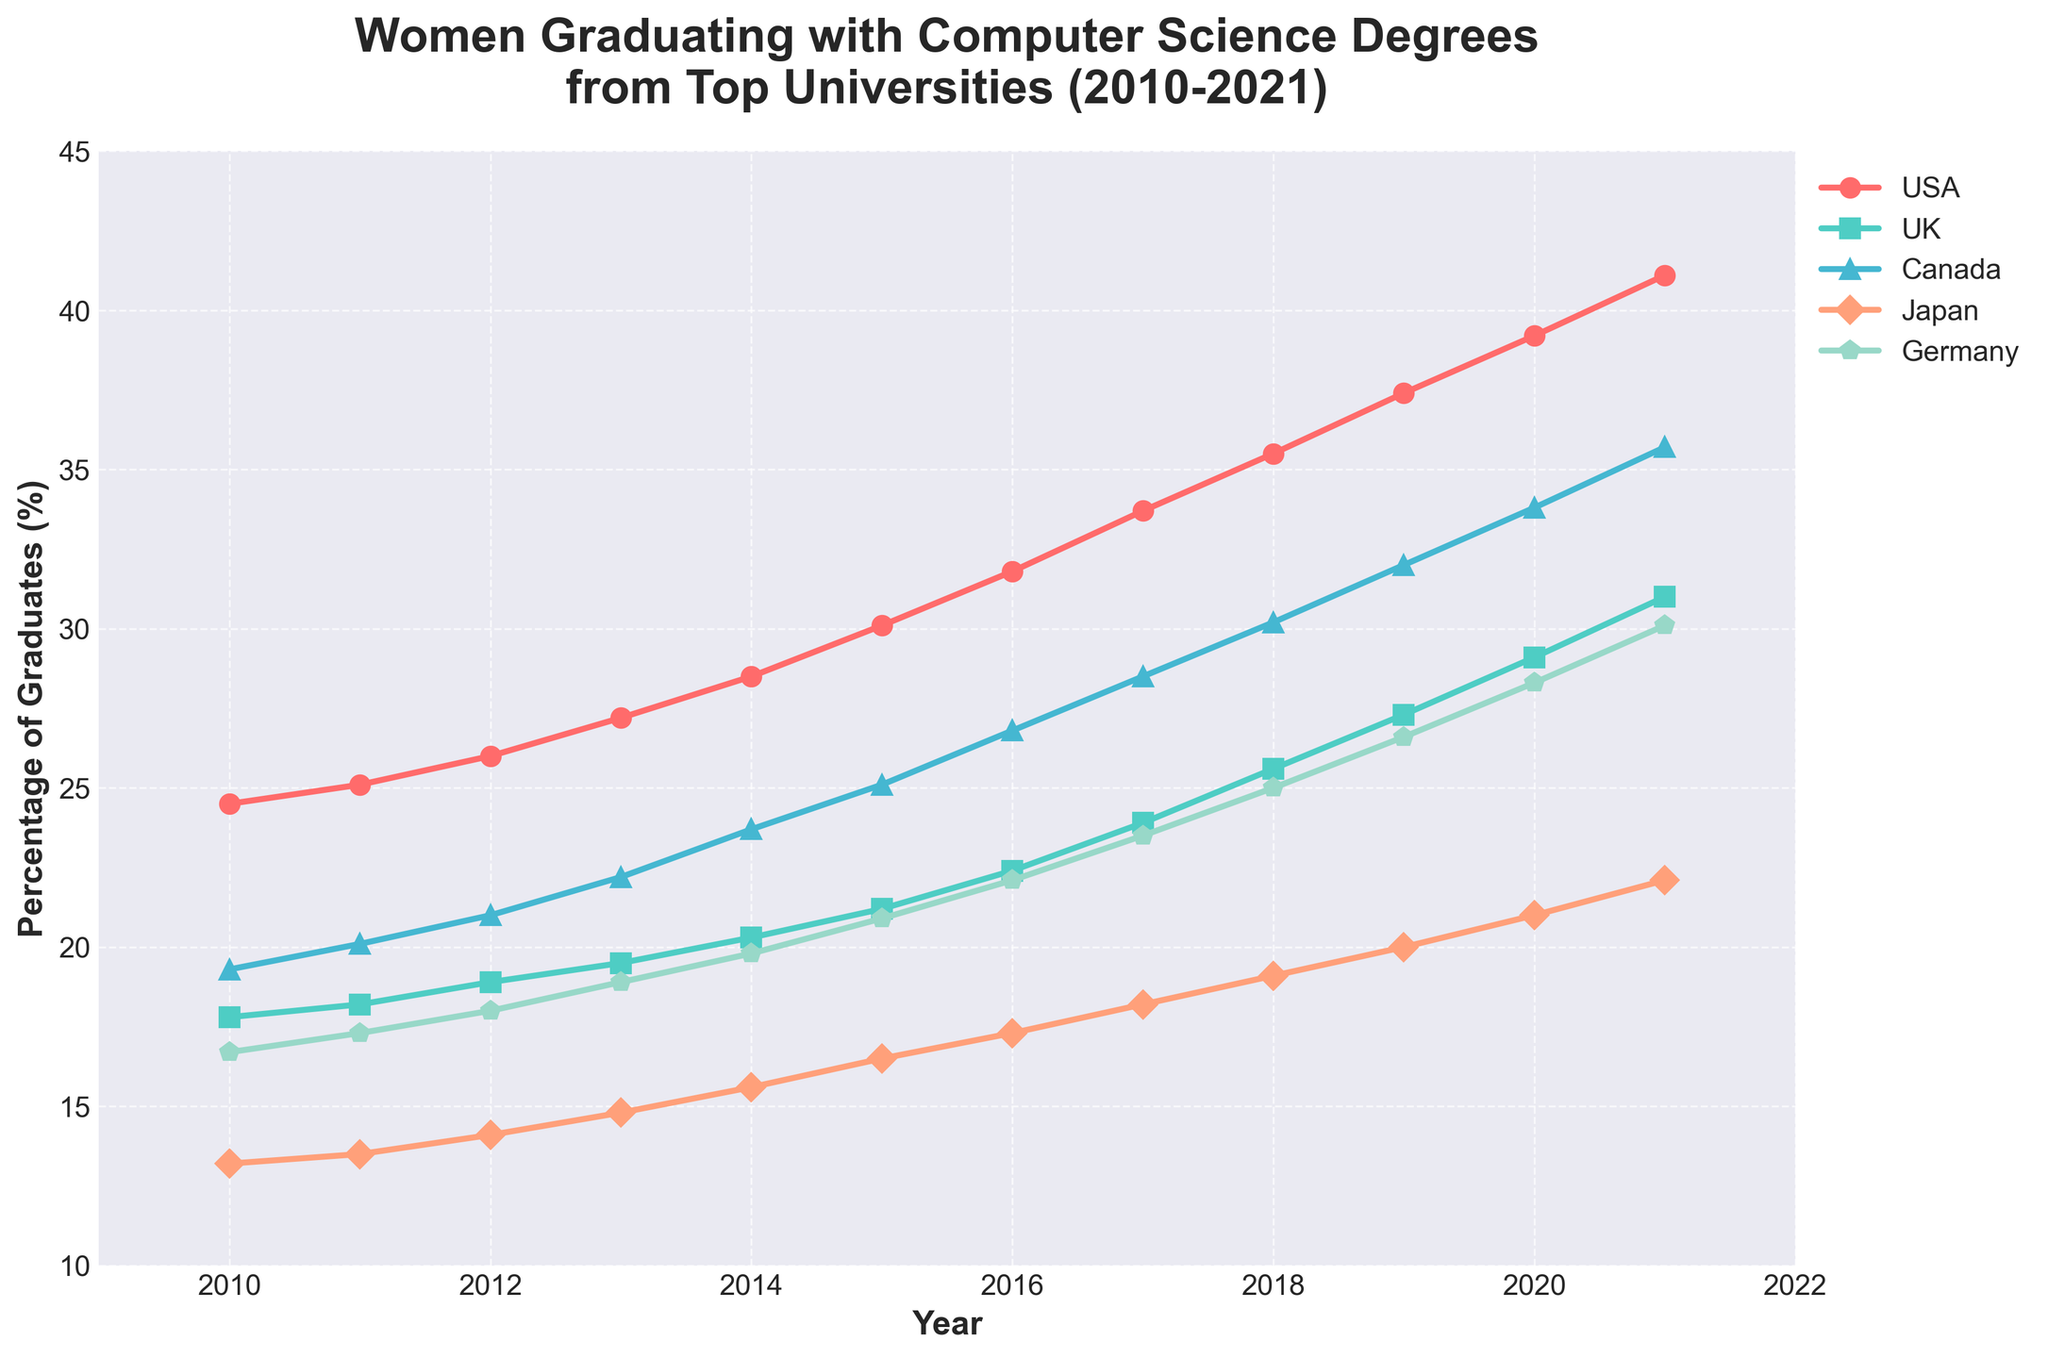What's the trend in the number of women graduating in the USA from 2010 to 2021? To determine the trend, look at the USA percentage values from 2010 to 2021 and note if they are increasing, decreasing, or fluctuating. The USA percentage values consistently increase from 24.5% in 2010 to 41.1% in 2021, which indicates an upward trend.
Answer: Upward trend Which year had the highest percentage of women graduates in Japan? To find the highest percentage of women graduates in Japan, scan through the percentage values for each year. The highest percentage for Japan is 22.1% in 2021.
Answer: 2021 Between the UK and Germany, which country saw a greater increase in women graduates from 2010 to 2021? Calculate the increase for both countries by subtracting the 2010 value from the 2021 value. For the UK: 31.0% - 17.8% = 13.2%. For Germany: 30.1% - 16.7% = 13.4%. Germany saw a greater increase.
Answer: Germany What's the average percentage of women graduates in Canada over the 12 years? To find the average, sum the yearly percentages for Canada from 2010 to 2021 and divide by the number of years. Sum: 19.3 + 20.1 + 21.0 + 22.2 + 23.7 + 25.1 + 26.8 + 28.5 + 30.2 + 32.0 + 33.8 + 35.7 = 318.4. Average: 318.4 / 12 ≈ 26.5%.
Answer: 26.5% Did any country have a year where the percentage of women graduates decreased compared to the previous year? Check the yearly values for each country and see if any values are lower than the previous year. Each country's percentage values consistently increase year-to-year with no decreases.
Answer: No By how many percentage points did the USA's percentage of women graduates increase from 2010 to 2021? Subtract the 2010 value from the 2021 value for the USA. 41.1% - 24.5% = 16.6 percentage points.
Answer: 16.6 Which country had the lowest percentage of women graduates in 2010 and what was the percentage? Compare the 2010 percentages for each country. Japan had the lowest percentage in 2010 with 13.2%.
Answer: Japan, 13.2% In what year did Canada surpass 30% of women graduates for the first time? Scan through Canada's yearly percentages and find the first year with a value over 30%. Canada surpassed 30% in 2018 with 30.2%.
Answer: 2018 Which country showed the most consistent yearly increase in the percentage of women graduates? To determine consistency, compare the yearly increments for each country. The USA shows the most consistent and steady increases in its yearly percentages, with an approximately 2% increase each year.
Answer: USA 